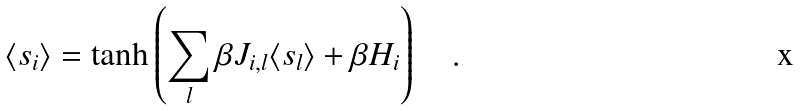Convert formula to latex. <formula><loc_0><loc_0><loc_500><loc_500>\langle s _ { i } \rangle = \tanh \left ( \sum _ { l } \beta J _ { i , l } \langle s _ { l } \rangle + \beta H _ { i } \right ) \quad .</formula> 